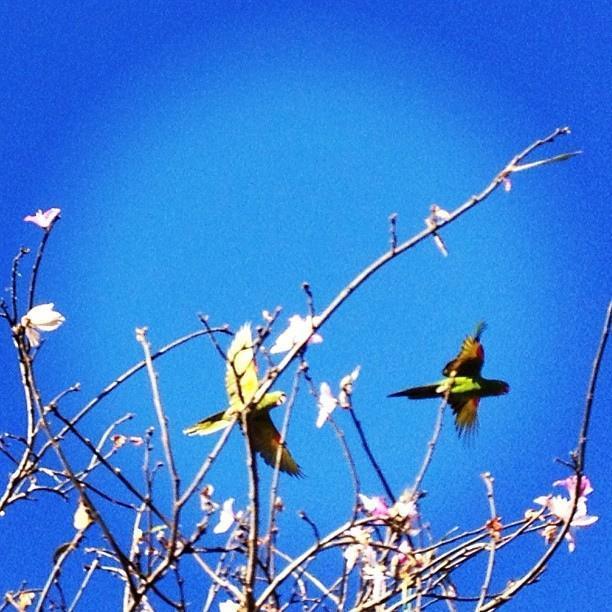How many birds are seen?
Give a very brief answer. 2. How many birds are there?
Give a very brief answer. 2. How many girl are there in the image?
Give a very brief answer. 0. 